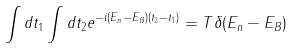<formula> <loc_0><loc_0><loc_500><loc_500>\int d t _ { 1 } \int d t _ { 2 } e ^ { - i ( E _ { n } - E _ { B } ) ( t _ { 2 } - t _ { 1 } ) } = T \delta ( E _ { n } - E _ { B } )</formula> 